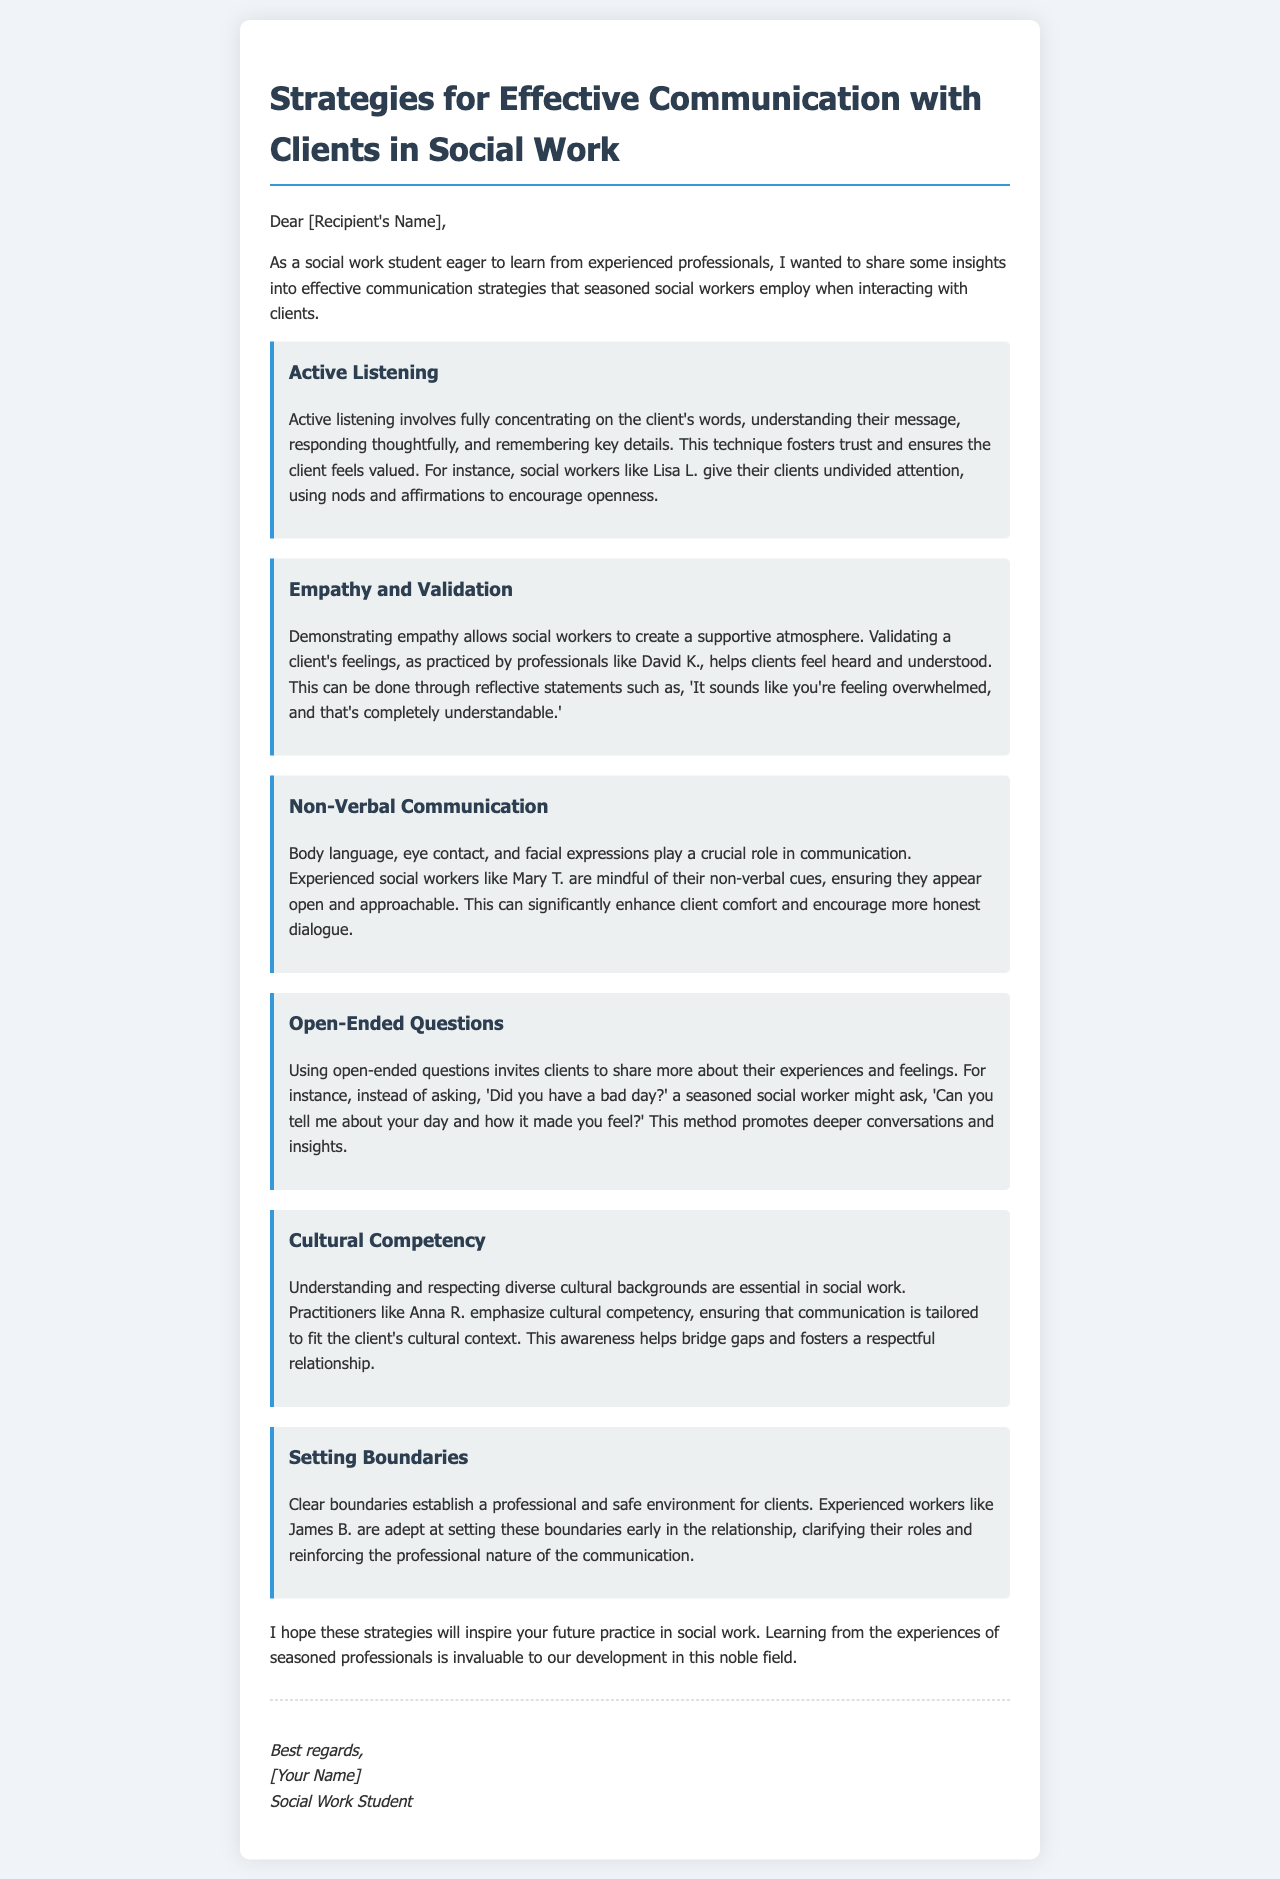What are the strategies mentioned for effective communication? The strategies outlined in the email include Active Listening, Empathy and Validation, Non-Verbal Communication, Open-Ended Questions, Cultural Competency, and Setting Boundaries.
Answer: Active Listening, Empathy and Validation, Non-Verbal Communication, Open-Ended Questions, Cultural Competency, Setting Boundaries Who is an example of a social worker that practices Active Listening? The document provides the name of Lisa L. as a seasoned social worker who practices Active Listening.
Answer: Lisa L What technique does David K. use in his practice? The document states that David K. employs Empathy and Validation in his interactions with clients.
Answer: Empathy and Validation Which strategy uses reflective statements? The strategy that uses reflective statements is Empathy and Validation, as indicated in the explanations provided in the email.
Answer: Empathy and Validation What role does cultural competency play in communication? The document explains that cultural competency helps ensure communication is tailored to fit the client's cultural context, fostering a respectful relationship.
Answer: Tailored to fit cultural context How do seasoned social workers like Mary T. enhance client comfort? The document mentions that Mary T. is mindful of her non-verbal cues, which enhances client comfort and encourages honest dialogue.
Answer: Non-verbal cues What type of questions do seasoned social workers use to promote deeper conversations? The email describes the use of open-ended questions to invite clients to share more about their experiences and feelings.
Answer: Open-ended questions What is the purpose of setting boundaries according to James B.? The document states that setting boundaries establishes a professional and safe environment for clients.
Answer: Establish a professional and safe environment Who is the intended audience of the email? The email is addressed to a specific recipient, constituting the intended audience, which is a social work student eager to learn from experienced professionals.
Answer: Social work student 